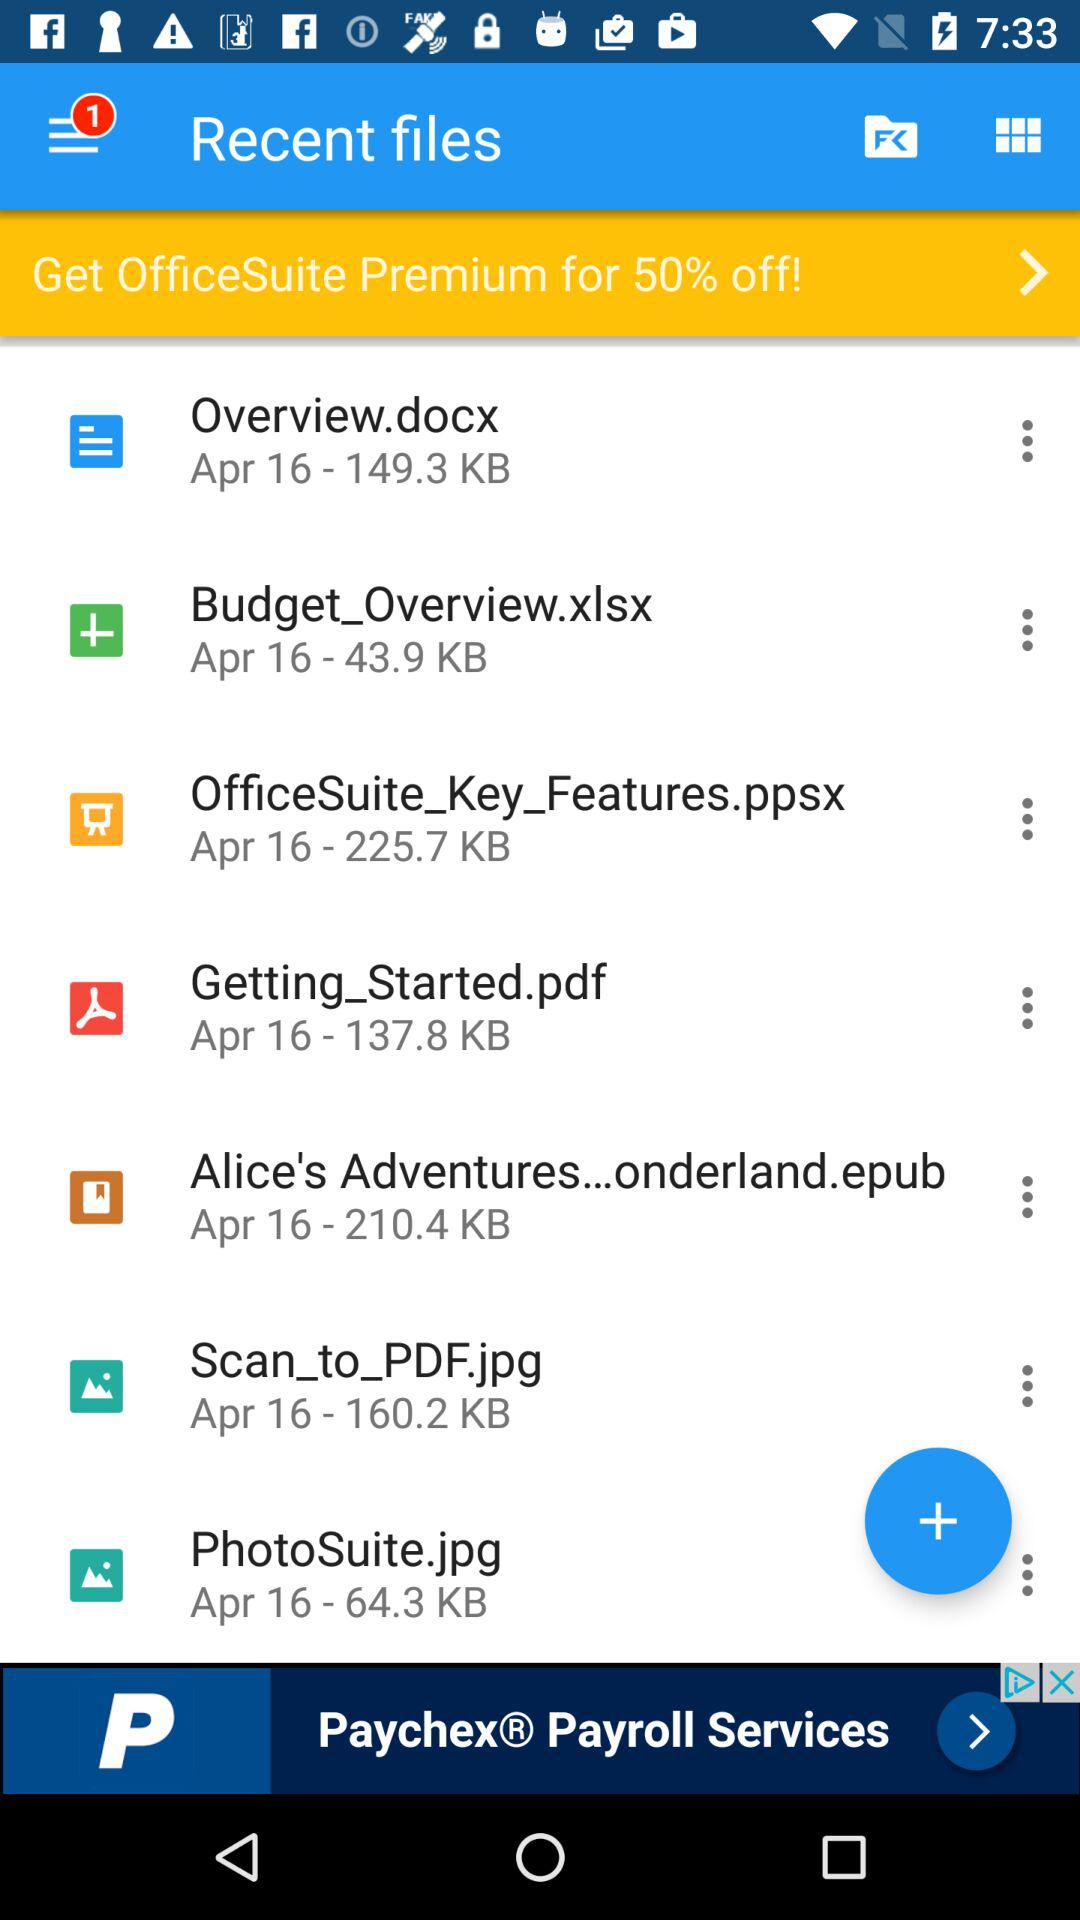What file has the size of 160.2 KB? The file is "Scan_to_PDF.jpg". 